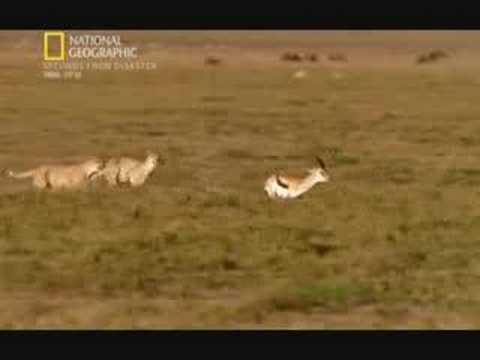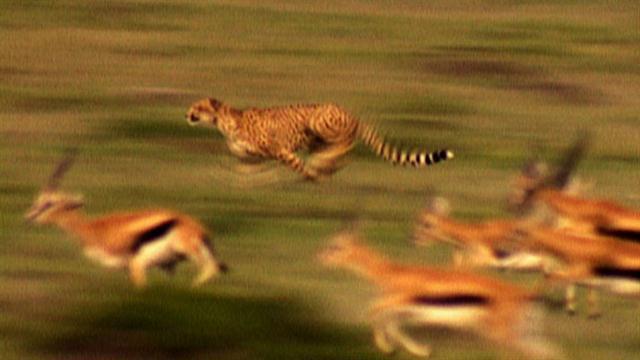The first image is the image on the left, the second image is the image on the right. Considering the images on both sides, is "In one image, a cheetah is about to capture a hooved animal as the cat strikes from behind the leftward-moving prey." valid? Answer yes or no. No. The first image is the image on the left, the second image is the image on the right. For the images displayed, is the sentence "In at least one image there is a single cheete with it's paw touch the elk it is chasing down." factually correct? Answer yes or no. No. 